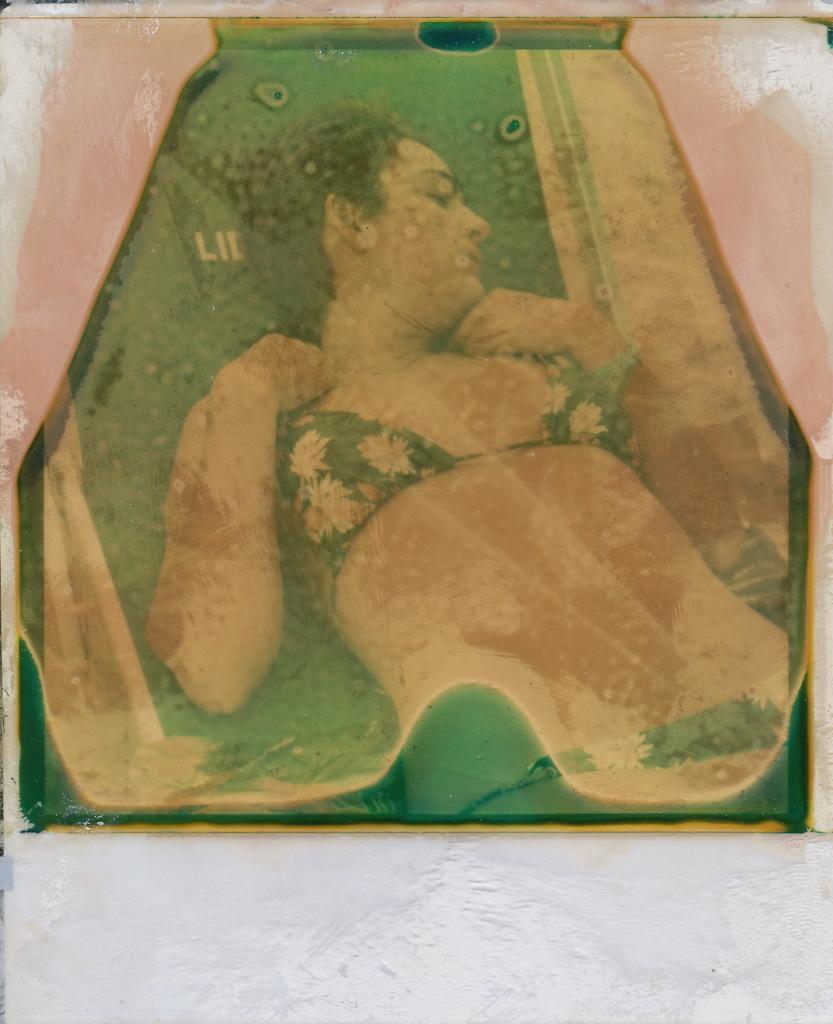In one or two sentences, can you explain what this image depicts? Here I can see a board which is attached to the wall. On the board, I can see a woman is lying. It seems like a painting. 